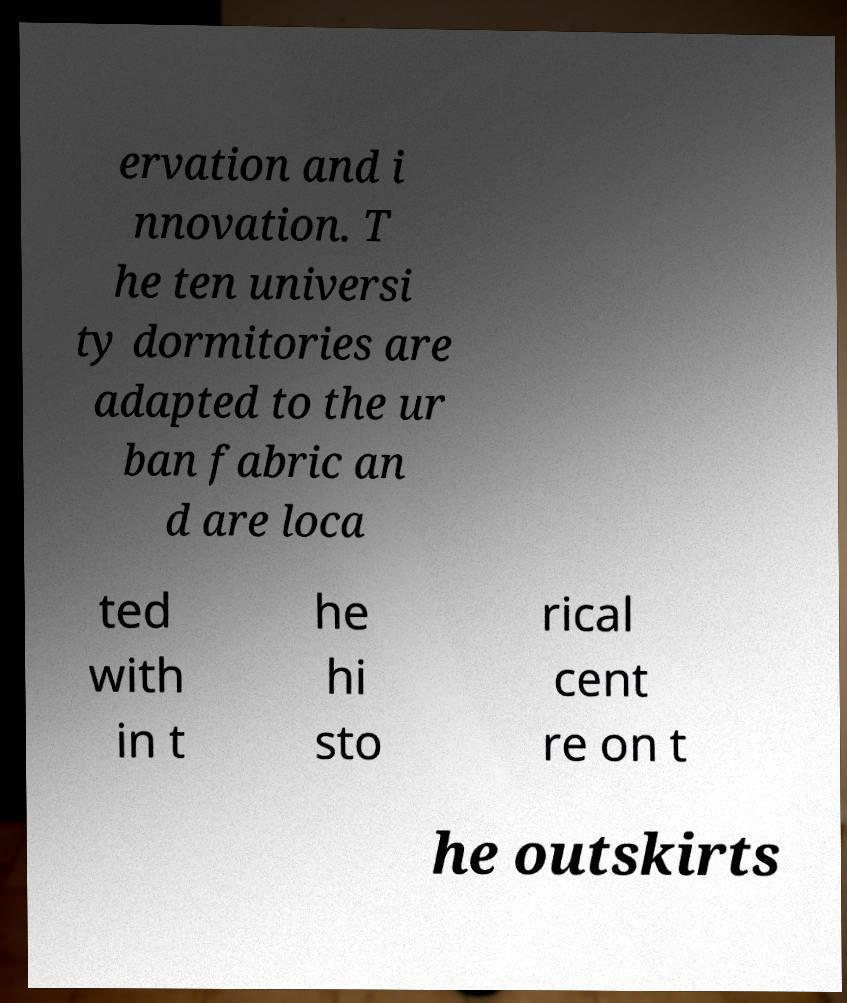Can you read and provide the text displayed in the image?This photo seems to have some interesting text. Can you extract and type it out for me? ervation and i nnovation. T he ten universi ty dormitories are adapted to the ur ban fabric an d are loca ted with in t he hi sto rical cent re on t he outskirts 